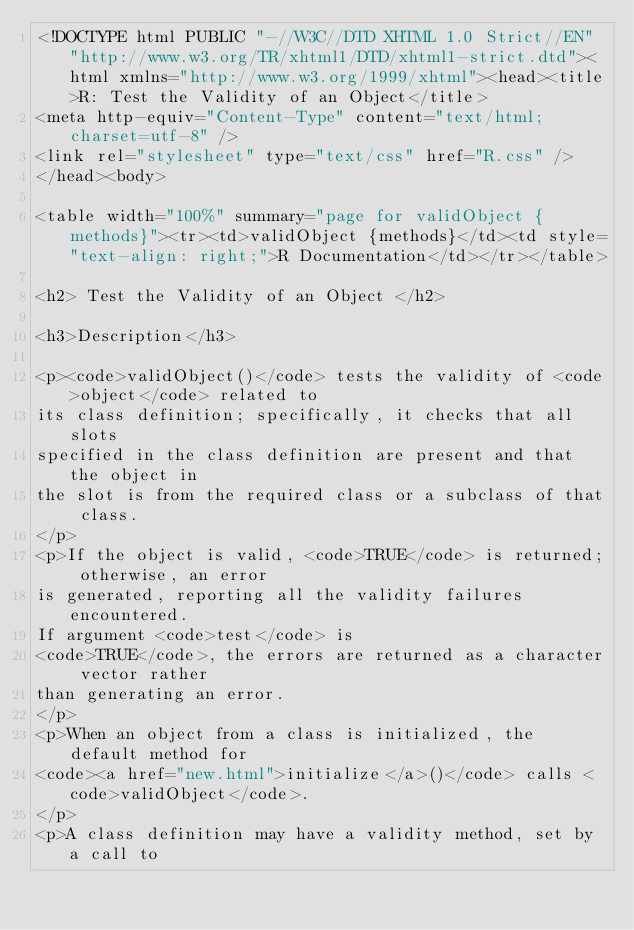Convert code to text. <code><loc_0><loc_0><loc_500><loc_500><_HTML_><!DOCTYPE html PUBLIC "-//W3C//DTD XHTML 1.0 Strict//EN" "http://www.w3.org/TR/xhtml1/DTD/xhtml1-strict.dtd"><html xmlns="http://www.w3.org/1999/xhtml"><head><title>R: Test the Validity of an Object</title>
<meta http-equiv="Content-Type" content="text/html; charset=utf-8" />
<link rel="stylesheet" type="text/css" href="R.css" />
</head><body>

<table width="100%" summary="page for validObject {methods}"><tr><td>validObject {methods}</td><td style="text-align: right;">R Documentation</td></tr></table>

<h2> Test the Validity of an Object </h2>

<h3>Description</h3>

<p><code>validObject()</code> tests the validity of <code>object</code> related to
its class definition; specifically, it checks that all slots
specified in the class definition are present and that the object in
the slot is from the required class or a subclass of that class.
</p>
<p>If the object is valid, <code>TRUE</code> is returned; otherwise, an error
is generated, reporting all the validity failures encountered.
If argument <code>test</code> is
<code>TRUE</code>, the errors are returned as a character vector rather
than generating an error.
</p>
<p>When an object from a class is initialized, the default method for
<code><a href="new.html">initialize</a>()</code> calls <code>validObject</code>.
</p>
<p>A class definition may have a validity method, set by a call to</code> 